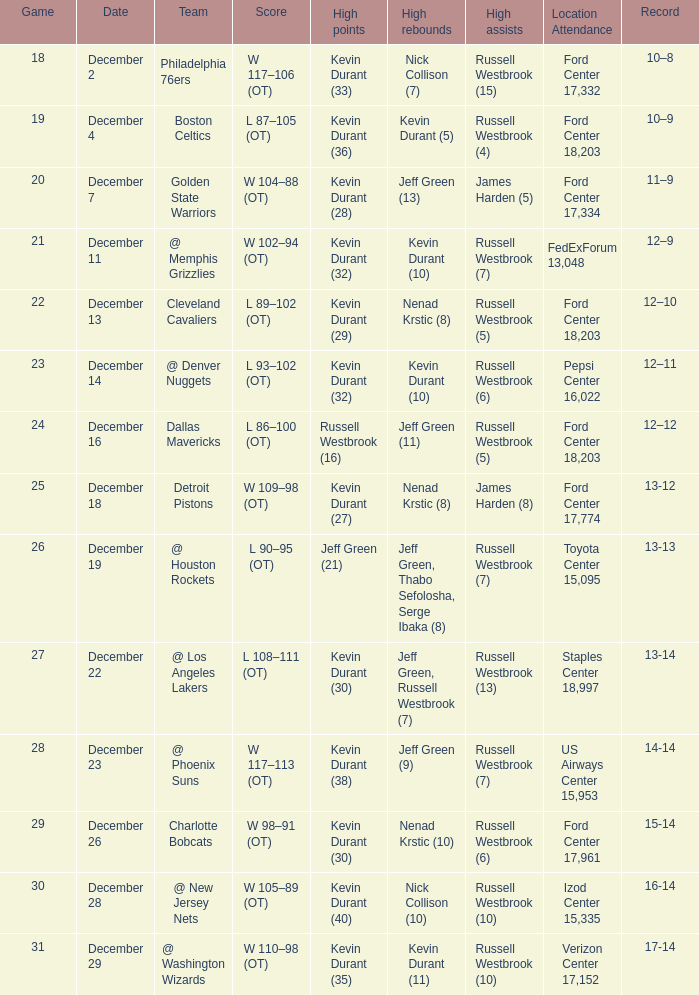Who has the highest scores when toyota center 15,095 is the location's attendance? Jeff Green (21). 